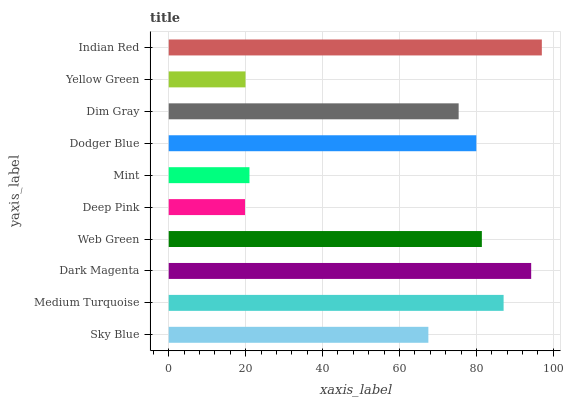Is Deep Pink the minimum?
Answer yes or no. Yes. Is Indian Red the maximum?
Answer yes or no. Yes. Is Medium Turquoise the minimum?
Answer yes or no. No. Is Medium Turquoise the maximum?
Answer yes or no. No. Is Medium Turquoise greater than Sky Blue?
Answer yes or no. Yes. Is Sky Blue less than Medium Turquoise?
Answer yes or no. Yes. Is Sky Blue greater than Medium Turquoise?
Answer yes or no. No. Is Medium Turquoise less than Sky Blue?
Answer yes or no. No. Is Dodger Blue the high median?
Answer yes or no. Yes. Is Dim Gray the low median?
Answer yes or no. Yes. Is Dim Gray the high median?
Answer yes or no. No. Is Yellow Green the low median?
Answer yes or no. No. 